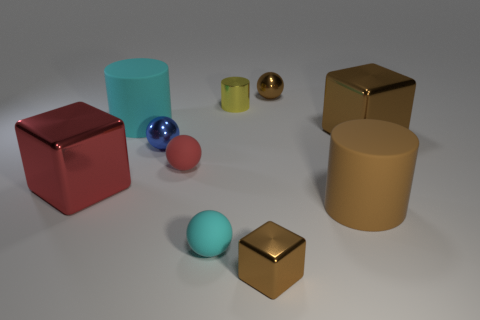There is a red sphere that is the same size as the blue metallic object; what is it made of? rubber 